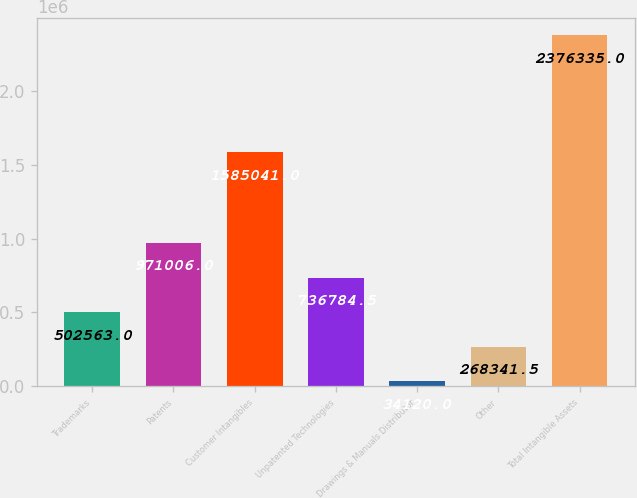<chart> <loc_0><loc_0><loc_500><loc_500><bar_chart><fcel>Trademarks<fcel>Patents<fcel>Customer Intangibles<fcel>Unpatented Technologies<fcel>Drawings & Manuals Distributor<fcel>Other<fcel>Total Intangible Assets<nl><fcel>502563<fcel>971006<fcel>1.58504e+06<fcel>736784<fcel>34120<fcel>268342<fcel>2.37634e+06<nl></chart> 